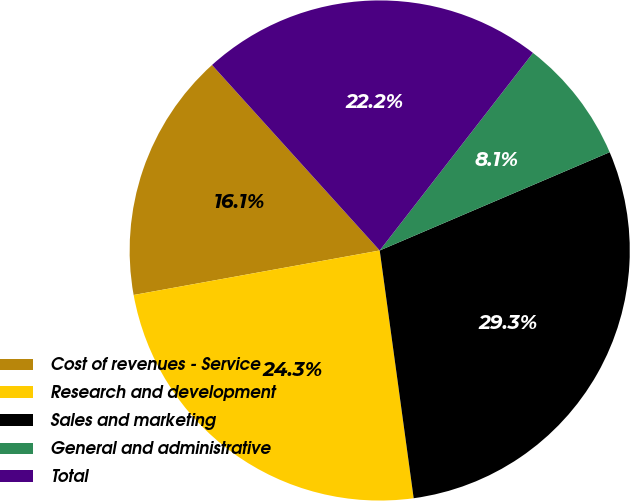Convert chart. <chart><loc_0><loc_0><loc_500><loc_500><pie_chart><fcel>Cost of revenues - Service<fcel>Research and development<fcel>Sales and marketing<fcel>General and administrative<fcel>Total<nl><fcel>16.15%<fcel>24.32%<fcel>29.26%<fcel>8.07%<fcel>22.2%<nl></chart> 